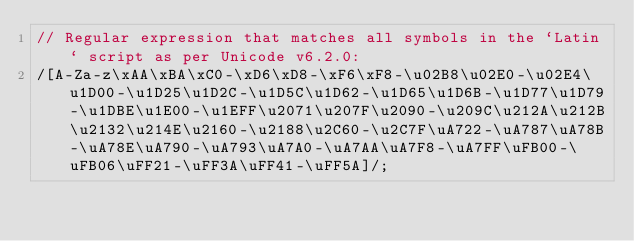<code> <loc_0><loc_0><loc_500><loc_500><_JavaScript_>// Regular expression that matches all symbols in the `Latin` script as per Unicode v6.2.0:
/[A-Za-z\xAA\xBA\xC0-\xD6\xD8-\xF6\xF8-\u02B8\u02E0-\u02E4\u1D00-\u1D25\u1D2C-\u1D5C\u1D62-\u1D65\u1D6B-\u1D77\u1D79-\u1DBE\u1E00-\u1EFF\u2071\u207F\u2090-\u209C\u212A\u212B\u2132\u214E\u2160-\u2188\u2C60-\u2C7F\uA722-\uA787\uA78B-\uA78E\uA790-\uA793\uA7A0-\uA7AA\uA7F8-\uA7FF\uFB00-\uFB06\uFF21-\uFF3A\uFF41-\uFF5A]/;</code> 